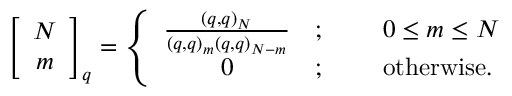Convert formula to latex. <formula><loc_0><loc_0><loc_500><loc_500>\, \left [ \begin{array} { c } { N } \\ { m } \end{array} \right ] _ { q } = \left \{ \begin{array} { c l l } { { \frac { ( q , q ) _ { N } } { ( q , q ) _ { m } ( q , q ) _ { N - m } } } } & { ; } & { \, 0 \leq m \leq N } \\ { 0 } & { ; } & { \, o t h e r w i s e . } \end{array}</formula> 